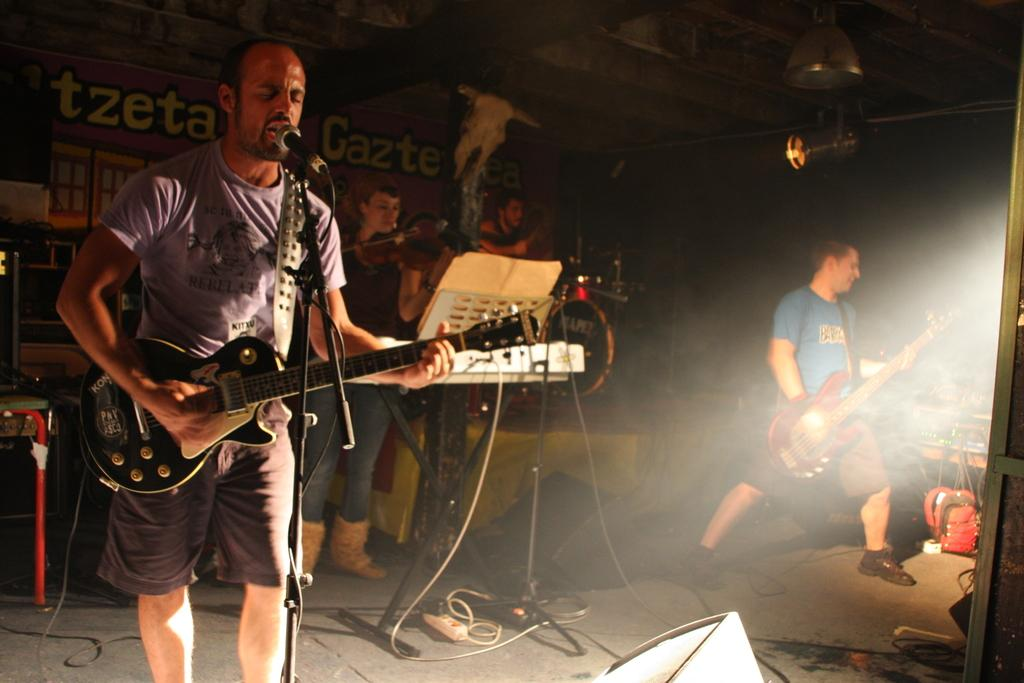How many people are in the image? There are three persons in the image. What are the persons doing in the image? The persons are playing musical instruments. Can you describe any objects on the floor in the image? Yes, there is a bag on the floor. What can be seen in the background of the image? There is a building in the background of the image. What type of songs does the son of the representative play in the image? There is no son or representative present in the image, and therefore no such activity can be observed. 